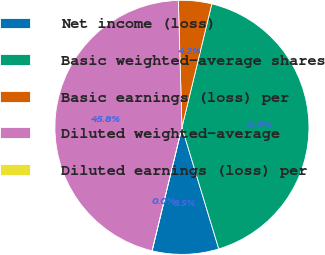Convert chart to OTSL. <chart><loc_0><loc_0><loc_500><loc_500><pie_chart><fcel>Net income (loss)<fcel>Basic weighted-average shares<fcel>Basic earnings (loss) per<fcel>Diluted weighted-average<fcel>Diluted earnings (loss) per<nl><fcel>8.46%<fcel>41.54%<fcel>4.23%<fcel>45.77%<fcel>0.0%<nl></chart> 